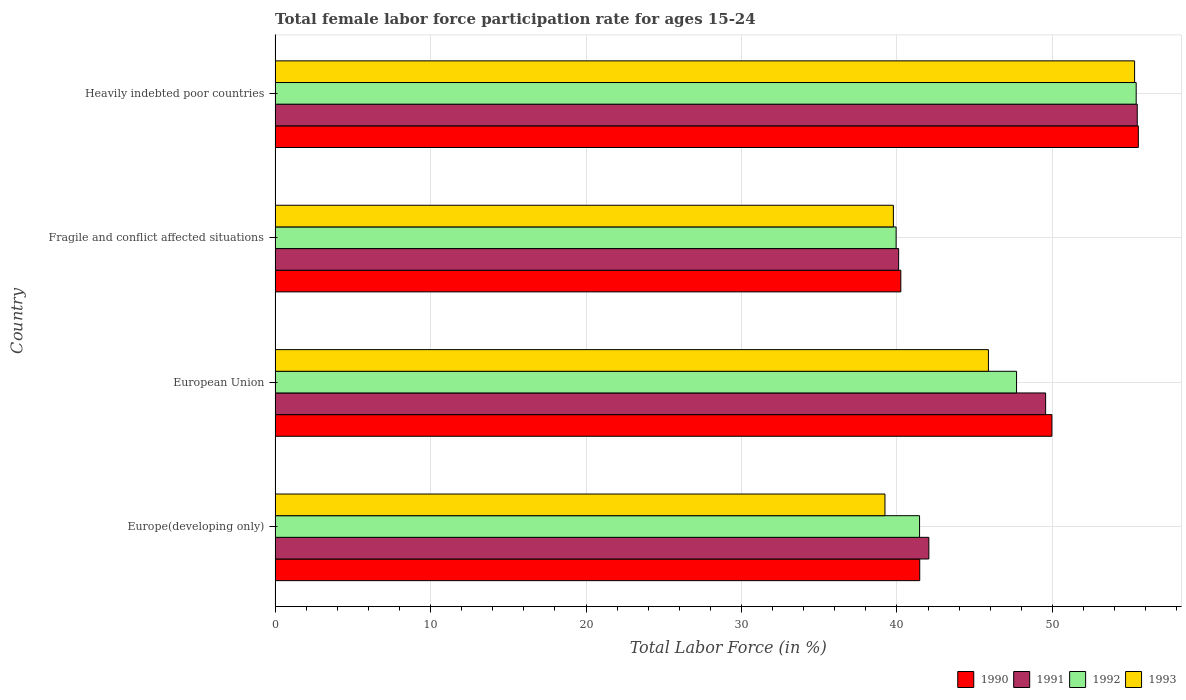How many bars are there on the 4th tick from the top?
Your response must be concise. 4. What is the label of the 1st group of bars from the top?
Provide a succinct answer. Heavily indebted poor countries. What is the female labor force participation rate in 1990 in Europe(developing only)?
Make the answer very short. 41.47. Across all countries, what is the maximum female labor force participation rate in 1992?
Your response must be concise. 55.39. Across all countries, what is the minimum female labor force participation rate in 1992?
Your response must be concise. 39.95. In which country was the female labor force participation rate in 1990 maximum?
Provide a succinct answer. Heavily indebted poor countries. In which country was the female labor force participation rate in 1992 minimum?
Provide a succinct answer. Fragile and conflict affected situations. What is the total female labor force participation rate in 1992 in the graph?
Your response must be concise. 184.49. What is the difference between the female labor force participation rate in 1992 in European Union and that in Fragile and conflict affected situations?
Provide a succinct answer. 7.75. What is the difference between the female labor force participation rate in 1993 in Fragile and conflict affected situations and the female labor force participation rate in 1990 in European Union?
Offer a terse response. -10.2. What is the average female labor force participation rate in 1991 per country?
Offer a very short reply. 46.8. What is the difference between the female labor force participation rate in 1993 and female labor force participation rate in 1992 in European Union?
Your answer should be very brief. -1.81. What is the ratio of the female labor force participation rate in 1992 in European Union to that in Heavily indebted poor countries?
Make the answer very short. 0.86. Is the female labor force participation rate in 1993 in European Union less than that in Fragile and conflict affected situations?
Your response must be concise. No. What is the difference between the highest and the second highest female labor force participation rate in 1990?
Ensure brevity in your answer.  5.56. What is the difference between the highest and the lowest female labor force participation rate in 1990?
Provide a succinct answer. 15.28. Is it the case that in every country, the sum of the female labor force participation rate in 1991 and female labor force participation rate in 1993 is greater than the female labor force participation rate in 1992?
Offer a very short reply. Yes. How many bars are there?
Your answer should be compact. 16. Are all the bars in the graph horizontal?
Your answer should be compact. Yes. What is the difference between two consecutive major ticks on the X-axis?
Give a very brief answer. 10. Does the graph contain any zero values?
Offer a very short reply. No. Does the graph contain grids?
Give a very brief answer. Yes. Where does the legend appear in the graph?
Offer a terse response. Bottom right. How many legend labels are there?
Provide a short and direct response. 4. What is the title of the graph?
Keep it short and to the point. Total female labor force participation rate for ages 15-24. What is the label or title of the Y-axis?
Make the answer very short. Country. What is the Total Labor Force (in %) of 1990 in Europe(developing only)?
Offer a very short reply. 41.47. What is the Total Labor Force (in %) in 1991 in Europe(developing only)?
Provide a short and direct response. 42.05. What is the Total Labor Force (in %) in 1992 in Europe(developing only)?
Offer a terse response. 41.46. What is the Total Labor Force (in %) in 1993 in Europe(developing only)?
Keep it short and to the point. 39.23. What is the Total Labor Force (in %) of 1990 in European Union?
Provide a succinct answer. 49.97. What is the Total Labor Force (in %) in 1991 in European Union?
Your answer should be compact. 49.57. What is the Total Labor Force (in %) of 1992 in European Union?
Offer a very short reply. 47.7. What is the Total Labor Force (in %) in 1993 in European Union?
Your response must be concise. 45.89. What is the Total Labor Force (in %) in 1990 in Fragile and conflict affected situations?
Offer a very short reply. 40.25. What is the Total Labor Force (in %) of 1991 in Fragile and conflict affected situations?
Offer a terse response. 40.11. What is the Total Labor Force (in %) of 1992 in Fragile and conflict affected situations?
Your answer should be very brief. 39.95. What is the Total Labor Force (in %) of 1993 in Fragile and conflict affected situations?
Provide a short and direct response. 39.77. What is the Total Labor Force (in %) of 1990 in Heavily indebted poor countries?
Give a very brief answer. 55.53. What is the Total Labor Force (in %) in 1991 in Heavily indebted poor countries?
Keep it short and to the point. 55.46. What is the Total Labor Force (in %) of 1992 in Heavily indebted poor countries?
Offer a terse response. 55.39. What is the Total Labor Force (in %) of 1993 in Heavily indebted poor countries?
Offer a terse response. 55.29. Across all countries, what is the maximum Total Labor Force (in %) in 1990?
Ensure brevity in your answer.  55.53. Across all countries, what is the maximum Total Labor Force (in %) of 1991?
Your response must be concise. 55.46. Across all countries, what is the maximum Total Labor Force (in %) in 1992?
Offer a terse response. 55.39. Across all countries, what is the maximum Total Labor Force (in %) of 1993?
Offer a very short reply. 55.29. Across all countries, what is the minimum Total Labor Force (in %) in 1990?
Give a very brief answer. 40.25. Across all countries, what is the minimum Total Labor Force (in %) in 1991?
Ensure brevity in your answer.  40.11. Across all countries, what is the minimum Total Labor Force (in %) of 1992?
Keep it short and to the point. 39.95. Across all countries, what is the minimum Total Labor Force (in %) of 1993?
Your answer should be very brief. 39.23. What is the total Total Labor Force (in %) in 1990 in the graph?
Your answer should be compact. 187.22. What is the total Total Labor Force (in %) in 1991 in the graph?
Provide a short and direct response. 187.19. What is the total Total Labor Force (in %) of 1992 in the graph?
Your response must be concise. 184.49. What is the total Total Labor Force (in %) in 1993 in the graph?
Offer a very short reply. 180.18. What is the difference between the Total Labor Force (in %) of 1990 in Europe(developing only) and that in European Union?
Your answer should be very brief. -8.5. What is the difference between the Total Labor Force (in %) of 1991 in Europe(developing only) and that in European Union?
Offer a terse response. -7.51. What is the difference between the Total Labor Force (in %) in 1992 in Europe(developing only) and that in European Union?
Offer a very short reply. -6.24. What is the difference between the Total Labor Force (in %) in 1993 in Europe(developing only) and that in European Union?
Your answer should be compact. -6.65. What is the difference between the Total Labor Force (in %) in 1990 in Europe(developing only) and that in Fragile and conflict affected situations?
Offer a very short reply. 1.22. What is the difference between the Total Labor Force (in %) of 1991 in Europe(developing only) and that in Fragile and conflict affected situations?
Give a very brief answer. 1.94. What is the difference between the Total Labor Force (in %) in 1992 in Europe(developing only) and that in Fragile and conflict affected situations?
Keep it short and to the point. 1.51. What is the difference between the Total Labor Force (in %) of 1993 in Europe(developing only) and that in Fragile and conflict affected situations?
Provide a short and direct response. -0.54. What is the difference between the Total Labor Force (in %) of 1990 in Europe(developing only) and that in Heavily indebted poor countries?
Give a very brief answer. -14.06. What is the difference between the Total Labor Force (in %) of 1991 in Europe(developing only) and that in Heavily indebted poor countries?
Provide a short and direct response. -13.41. What is the difference between the Total Labor Force (in %) of 1992 in Europe(developing only) and that in Heavily indebted poor countries?
Make the answer very short. -13.93. What is the difference between the Total Labor Force (in %) in 1993 in Europe(developing only) and that in Heavily indebted poor countries?
Your answer should be very brief. -16.06. What is the difference between the Total Labor Force (in %) of 1990 in European Union and that in Fragile and conflict affected situations?
Offer a terse response. 9.72. What is the difference between the Total Labor Force (in %) of 1991 in European Union and that in Fragile and conflict affected situations?
Your answer should be very brief. 9.46. What is the difference between the Total Labor Force (in %) of 1992 in European Union and that in Fragile and conflict affected situations?
Your answer should be compact. 7.75. What is the difference between the Total Labor Force (in %) of 1993 in European Union and that in Fragile and conflict affected situations?
Offer a very short reply. 6.11. What is the difference between the Total Labor Force (in %) of 1990 in European Union and that in Heavily indebted poor countries?
Keep it short and to the point. -5.56. What is the difference between the Total Labor Force (in %) of 1991 in European Union and that in Heavily indebted poor countries?
Make the answer very short. -5.89. What is the difference between the Total Labor Force (in %) in 1992 in European Union and that in Heavily indebted poor countries?
Make the answer very short. -7.7. What is the difference between the Total Labor Force (in %) in 1993 in European Union and that in Heavily indebted poor countries?
Your response must be concise. -9.4. What is the difference between the Total Labor Force (in %) of 1990 in Fragile and conflict affected situations and that in Heavily indebted poor countries?
Provide a succinct answer. -15.28. What is the difference between the Total Labor Force (in %) of 1991 in Fragile and conflict affected situations and that in Heavily indebted poor countries?
Give a very brief answer. -15.35. What is the difference between the Total Labor Force (in %) of 1992 in Fragile and conflict affected situations and that in Heavily indebted poor countries?
Offer a very short reply. -15.44. What is the difference between the Total Labor Force (in %) of 1993 in Fragile and conflict affected situations and that in Heavily indebted poor countries?
Offer a very short reply. -15.52. What is the difference between the Total Labor Force (in %) in 1990 in Europe(developing only) and the Total Labor Force (in %) in 1991 in European Union?
Ensure brevity in your answer.  -8.1. What is the difference between the Total Labor Force (in %) of 1990 in Europe(developing only) and the Total Labor Force (in %) of 1992 in European Union?
Ensure brevity in your answer.  -6.23. What is the difference between the Total Labor Force (in %) of 1990 in Europe(developing only) and the Total Labor Force (in %) of 1993 in European Union?
Make the answer very short. -4.42. What is the difference between the Total Labor Force (in %) in 1991 in Europe(developing only) and the Total Labor Force (in %) in 1992 in European Union?
Offer a very short reply. -5.64. What is the difference between the Total Labor Force (in %) in 1991 in Europe(developing only) and the Total Labor Force (in %) in 1993 in European Union?
Provide a short and direct response. -3.83. What is the difference between the Total Labor Force (in %) in 1992 in Europe(developing only) and the Total Labor Force (in %) in 1993 in European Union?
Your answer should be very brief. -4.43. What is the difference between the Total Labor Force (in %) of 1990 in Europe(developing only) and the Total Labor Force (in %) of 1991 in Fragile and conflict affected situations?
Offer a very short reply. 1.36. What is the difference between the Total Labor Force (in %) of 1990 in Europe(developing only) and the Total Labor Force (in %) of 1992 in Fragile and conflict affected situations?
Provide a succinct answer. 1.52. What is the difference between the Total Labor Force (in %) of 1990 in Europe(developing only) and the Total Labor Force (in %) of 1993 in Fragile and conflict affected situations?
Your response must be concise. 1.7. What is the difference between the Total Labor Force (in %) of 1991 in Europe(developing only) and the Total Labor Force (in %) of 1992 in Fragile and conflict affected situations?
Provide a short and direct response. 2.11. What is the difference between the Total Labor Force (in %) in 1991 in Europe(developing only) and the Total Labor Force (in %) in 1993 in Fragile and conflict affected situations?
Keep it short and to the point. 2.28. What is the difference between the Total Labor Force (in %) of 1992 in Europe(developing only) and the Total Labor Force (in %) of 1993 in Fragile and conflict affected situations?
Provide a short and direct response. 1.68. What is the difference between the Total Labor Force (in %) in 1990 in Europe(developing only) and the Total Labor Force (in %) in 1991 in Heavily indebted poor countries?
Ensure brevity in your answer.  -13.99. What is the difference between the Total Labor Force (in %) in 1990 in Europe(developing only) and the Total Labor Force (in %) in 1992 in Heavily indebted poor countries?
Give a very brief answer. -13.92. What is the difference between the Total Labor Force (in %) of 1990 in Europe(developing only) and the Total Labor Force (in %) of 1993 in Heavily indebted poor countries?
Offer a terse response. -13.82. What is the difference between the Total Labor Force (in %) of 1991 in Europe(developing only) and the Total Labor Force (in %) of 1992 in Heavily indebted poor countries?
Offer a very short reply. -13.34. What is the difference between the Total Labor Force (in %) in 1991 in Europe(developing only) and the Total Labor Force (in %) in 1993 in Heavily indebted poor countries?
Provide a succinct answer. -13.23. What is the difference between the Total Labor Force (in %) of 1992 in Europe(developing only) and the Total Labor Force (in %) of 1993 in Heavily indebted poor countries?
Your answer should be very brief. -13.83. What is the difference between the Total Labor Force (in %) in 1990 in European Union and the Total Labor Force (in %) in 1991 in Fragile and conflict affected situations?
Give a very brief answer. 9.86. What is the difference between the Total Labor Force (in %) in 1990 in European Union and the Total Labor Force (in %) in 1992 in Fragile and conflict affected situations?
Give a very brief answer. 10.02. What is the difference between the Total Labor Force (in %) in 1990 in European Union and the Total Labor Force (in %) in 1993 in Fragile and conflict affected situations?
Your response must be concise. 10.2. What is the difference between the Total Labor Force (in %) in 1991 in European Union and the Total Labor Force (in %) in 1992 in Fragile and conflict affected situations?
Provide a short and direct response. 9.62. What is the difference between the Total Labor Force (in %) of 1991 in European Union and the Total Labor Force (in %) of 1993 in Fragile and conflict affected situations?
Offer a terse response. 9.79. What is the difference between the Total Labor Force (in %) of 1992 in European Union and the Total Labor Force (in %) of 1993 in Fragile and conflict affected situations?
Provide a short and direct response. 7.92. What is the difference between the Total Labor Force (in %) of 1990 in European Union and the Total Labor Force (in %) of 1991 in Heavily indebted poor countries?
Ensure brevity in your answer.  -5.49. What is the difference between the Total Labor Force (in %) in 1990 in European Union and the Total Labor Force (in %) in 1992 in Heavily indebted poor countries?
Offer a terse response. -5.42. What is the difference between the Total Labor Force (in %) of 1990 in European Union and the Total Labor Force (in %) of 1993 in Heavily indebted poor countries?
Offer a very short reply. -5.32. What is the difference between the Total Labor Force (in %) of 1991 in European Union and the Total Labor Force (in %) of 1992 in Heavily indebted poor countries?
Offer a very short reply. -5.83. What is the difference between the Total Labor Force (in %) of 1991 in European Union and the Total Labor Force (in %) of 1993 in Heavily indebted poor countries?
Offer a very short reply. -5.72. What is the difference between the Total Labor Force (in %) of 1992 in European Union and the Total Labor Force (in %) of 1993 in Heavily indebted poor countries?
Give a very brief answer. -7.59. What is the difference between the Total Labor Force (in %) in 1990 in Fragile and conflict affected situations and the Total Labor Force (in %) in 1991 in Heavily indebted poor countries?
Ensure brevity in your answer.  -15.21. What is the difference between the Total Labor Force (in %) in 1990 in Fragile and conflict affected situations and the Total Labor Force (in %) in 1992 in Heavily indebted poor countries?
Keep it short and to the point. -15.14. What is the difference between the Total Labor Force (in %) of 1990 in Fragile and conflict affected situations and the Total Labor Force (in %) of 1993 in Heavily indebted poor countries?
Your answer should be very brief. -15.04. What is the difference between the Total Labor Force (in %) in 1991 in Fragile and conflict affected situations and the Total Labor Force (in %) in 1992 in Heavily indebted poor countries?
Give a very brief answer. -15.28. What is the difference between the Total Labor Force (in %) of 1991 in Fragile and conflict affected situations and the Total Labor Force (in %) of 1993 in Heavily indebted poor countries?
Your answer should be very brief. -15.18. What is the difference between the Total Labor Force (in %) in 1992 in Fragile and conflict affected situations and the Total Labor Force (in %) in 1993 in Heavily indebted poor countries?
Your answer should be compact. -15.34. What is the average Total Labor Force (in %) in 1990 per country?
Ensure brevity in your answer.  46.8. What is the average Total Labor Force (in %) of 1991 per country?
Ensure brevity in your answer.  46.8. What is the average Total Labor Force (in %) of 1992 per country?
Keep it short and to the point. 46.12. What is the average Total Labor Force (in %) in 1993 per country?
Ensure brevity in your answer.  45.05. What is the difference between the Total Labor Force (in %) of 1990 and Total Labor Force (in %) of 1991 in Europe(developing only)?
Your answer should be very brief. -0.59. What is the difference between the Total Labor Force (in %) of 1990 and Total Labor Force (in %) of 1992 in Europe(developing only)?
Give a very brief answer. 0.01. What is the difference between the Total Labor Force (in %) in 1990 and Total Labor Force (in %) in 1993 in Europe(developing only)?
Keep it short and to the point. 2.24. What is the difference between the Total Labor Force (in %) in 1991 and Total Labor Force (in %) in 1992 in Europe(developing only)?
Your response must be concise. 0.6. What is the difference between the Total Labor Force (in %) in 1991 and Total Labor Force (in %) in 1993 in Europe(developing only)?
Make the answer very short. 2.82. What is the difference between the Total Labor Force (in %) in 1992 and Total Labor Force (in %) in 1993 in Europe(developing only)?
Provide a succinct answer. 2.23. What is the difference between the Total Labor Force (in %) in 1990 and Total Labor Force (in %) in 1991 in European Union?
Provide a succinct answer. 0.4. What is the difference between the Total Labor Force (in %) of 1990 and Total Labor Force (in %) of 1992 in European Union?
Your answer should be compact. 2.27. What is the difference between the Total Labor Force (in %) in 1990 and Total Labor Force (in %) in 1993 in European Union?
Give a very brief answer. 4.08. What is the difference between the Total Labor Force (in %) of 1991 and Total Labor Force (in %) of 1992 in European Union?
Your response must be concise. 1.87. What is the difference between the Total Labor Force (in %) of 1991 and Total Labor Force (in %) of 1993 in European Union?
Ensure brevity in your answer.  3.68. What is the difference between the Total Labor Force (in %) in 1992 and Total Labor Force (in %) in 1993 in European Union?
Offer a terse response. 1.81. What is the difference between the Total Labor Force (in %) of 1990 and Total Labor Force (in %) of 1991 in Fragile and conflict affected situations?
Your response must be concise. 0.14. What is the difference between the Total Labor Force (in %) in 1990 and Total Labor Force (in %) in 1992 in Fragile and conflict affected situations?
Offer a terse response. 0.3. What is the difference between the Total Labor Force (in %) of 1990 and Total Labor Force (in %) of 1993 in Fragile and conflict affected situations?
Make the answer very short. 0.48. What is the difference between the Total Labor Force (in %) in 1991 and Total Labor Force (in %) in 1992 in Fragile and conflict affected situations?
Offer a very short reply. 0.16. What is the difference between the Total Labor Force (in %) of 1991 and Total Labor Force (in %) of 1993 in Fragile and conflict affected situations?
Provide a short and direct response. 0.34. What is the difference between the Total Labor Force (in %) in 1992 and Total Labor Force (in %) in 1993 in Fragile and conflict affected situations?
Offer a terse response. 0.18. What is the difference between the Total Labor Force (in %) of 1990 and Total Labor Force (in %) of 1991 in Heavily indebted poor countries?
Your answer should be very brief. 0.07. What is the difference between the Total Labor Force (in %) of 1990 and Total Labor Force (in %) of 1992 in Heavily indebted poor countries?
Provide a short and direct response. 0.14. What is the difference between the Total Labor Force (in %) in 1990 and Total Labor Force (in %) in 1993 in Heavily indebted poor countries?
Offer a very short reply. 0.24. What is the difference between the Total Labor Force (in %) of 1991 and Total Labor Force (in %) of 1992 in Heavily indebted poor countries?
Make the answer very short. 0.07. What is the difference between the Total Labor Force (in %) in 1991 and Total Labor Force (in %) in 1993 in Heavily indebted poor countries?
Provide a succinct answer. 0.17. What is the difference between the Total Labor Force (in %) in 1992 and Total Labor Force (in %) in 1993 in Heavily indebted poor countries?
Ensure brevity in your answer.  0.1. What is the ratio of the Total Labor Force (in %) in 1990 in Europe(developing only) to that in European Union?
Keep it short and to the point. 0.83. What is the ratio of the Total Labor Force (in %) of 1991 in Europe(developing only) to that in European Union?
Your response must be concise. 0.85. What is the ratio of the Total Labor Force (in %) in 1992 in Europe(developing only) to that in European Union?
Ensure brevity in your answer.  0.87. What is the ratio of the Total Labor Force (in %) of 1993 in Europe(developing only) to that in European Union?
Provide a short and direct response. 0.85. What is the ratio of the Total Labor Force (in %) of 1990 in Europe(developing only) to that in Fragile and conflict affected situations?
Provide a succinct answer. 1.03. What is the ratio of the Total Labor Force (in %) of 1991 in Europe(developing only) to that in Fragile and conflict affected situations?
Offer a terse response. 1.05. What is the ratio of the Total Labor Force (in %) of 1992 in Europe(developing only) to that in Fragile and conflict affected situations?
Your response must be concise. 1.04. What is the ratio of the Total Labor Force (in %) in 1993 in Europe(developing only) to that in Fragile and conflict affected situations?
Provide a succinct answer. 0.99. What is the ratio of the Total Labor Force (in %) in 1990 in Europe(developing only) to that in Heavily indebted poor countries?
Make the answer very short. 0.75. What is the ratio of the Total Labor Force (in %) of 1991 in Europe(developing only) to that in Heavily indebted poor countries?
Offer a terse response. 0.76. What is the ratio of the Total Labor Force (in %) of 1992 in Europe(developing only) to that in Heavily indebted poor countries?
Make the answer very short. 0.75. What is the ratio of the Total Labor Force (in %) of 1993 in Europe(developing only) to that in Heavily indebted poor countries?
Provide a short and direct response. 0.71. What is the ratio of the Total Labor Force (in %) in 1990 in European Union to that in Fragile and conflict affected situations?
Keep it short and to the point. 1.24. What is the ratio of the Total Labor Force (in %) in 1991 in European Union to that in Fragile and conflict affected situations?
Offer a very short reply. 1.24. What is the ratio of the Total Labor Force (in %) of 1992 in European Union to that in Fragile and conflict affected situations?
Ensure brevity in your answer.  1.19. What is the ratio of the Total Labor Force (in %) of 1993 in European Union to that in Fragile and conflict affected situations?
Give a very brief answer. 1.15. What is the ratio of the Total Labor Force (in %) in 1990 in European Union to that in Heavily indebted poor countries?
Your answer should be very brief. 0.9. What is the ratio of the Total Labor Force (in %) of 1991 in European Union to that in Heavily indebted poor countries?
Provide a succinct answer. 0.89. What is the ratio of the Total Labor Force (in %) of 1992 in European Union to that in Heavily indebted poor countries?
Ensure brevity in your answer.  0.86. What is the ratio of the Total Labor Force (in %) in 1993 in European Union to that in Heavily indebted poor countries?
Your answer should be compact. 0.83. What is the ratio of the Total Labor Force (in %) of 1990 in Fragile and conflict affected situations to that in Heavily indebted poor countries?
Provide a short and direct response. 0.72. What is the ratio of the Total Labor Force (in %) in 1991 in Fragile and conflict affected situations to that in Heavily indebted poor countries?
Your answer should be compact. 0.72. What is the ratio of the Total Labor Force (in %) of 1992 in Fragile and conflict affected situations to that in Heavily indebted poor countries?
Ensure brevity in your answer.  0.72. What is the ratio of the Total Labor Force (in %) of 1993 in Fragile and conflict affected situations to that in Heavily indebted poor countries?
Provide a short and direct response. 0.72. What is the difference between the highest and the second highest Total Labor Force (in %) in 1990?
Provide a short and direct response. 5.56. What is the difference between the highest and the second highest Total Labor Force (in %) in 1991?
Ensure brevity in your answer.  5.89. What is the difference between the highest and the second highest Total Labor Force (in %) in 1992?
Make the answer very short. 7.7. What is the difference between the highest and the second highest Total Labor Force (in %) in 1993?
Give a very brief answer. 9.4. What is the difference between the highest and the lowest Total Labor Force (in %) of 1990?
Your response must be concise. 15.28. What is the difference between the highest and the lowest Total Labor Force (in %) in 1991?
Give a very brief answer. 15.35. What is the difference between the highest and the lowest Total Labor Force (in %) of 1992?
Your response must be concise. 15.44. What is the difference between the highest and the lowest Total Labor Force (in %) in 1993?
Make the answer very short. 16.06. 